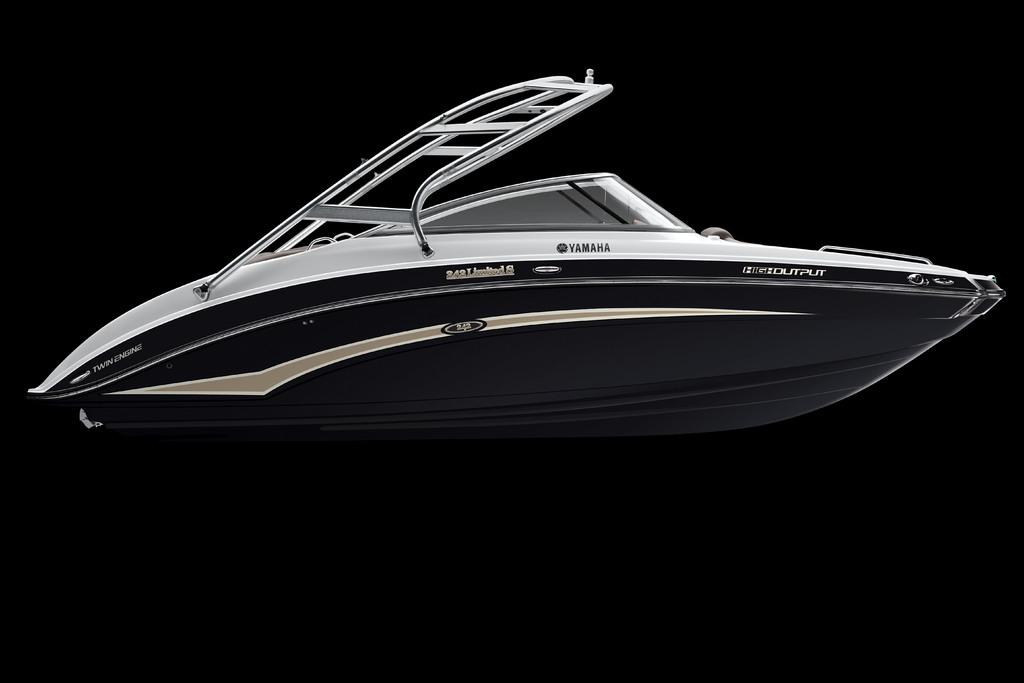What company made this boat?
Ensure brevity in your answer.  Yamaha. What type of boat is this?
Your response must be concise. Yamaha. 